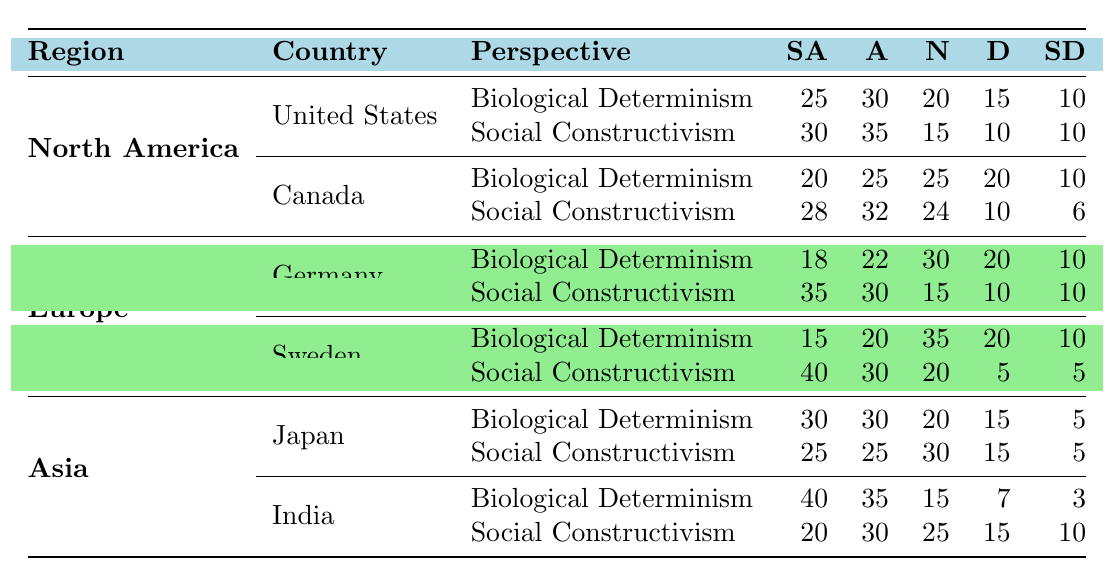What percentage of respondents in Canada agree with Social Constructivism? In Canada, for Social Constructivism, the 'Agree' category has a value of 32. To find the percentage of respondents who agree, we refer to the total counts in Social Constructivism: 28 (Strongly Agree) + 32 (Agree) + 24 (Neutral) + 10 (Disagree) + 6 (Strongly Disagree) = 100. The percentage that agree is (32/100) * 100 = 32%.
Answer: 32% Which country shows the highest level of agreement with Biological Determinism? Examining the values under Biological Determinism, India has the highest 'Strongly Agree' count at 40, while other countries have lower values (the highest is 30 in Japan and the US). Therefore, India shows the highest level of agreement.
Answer: India What is the average percentage of respondents in the United States who agree with Biological Determinism and Social Constructivism combined? For the United States, the values for agreeing (Strongly Agree + Agree) in Biological Determinism are 25 + 30 = 55, and for Social Constructivism are 30 + 35 = 65. Combining them gives: 55 + 65 = 120. There are 2 perspectives, so the average is 120 / 2 = 60%.
Answer: 60% Is it true that Sweden has a higher percentage of respondents agreeing with Social Constructivism than Germany? In Sweden, the combined agreement for Social Constructivism (Strongly Agree + Agree) is 40 + 30 = 70. For Germany, it's 35 + 30 = 65. 70 is greater than 65, thus it is true that Sweden has a higher percentage of agreement compared to Germany.
Answer: Yes What is the difference in the percentage of respondents who strongly agree with Biological Determinism between Japan and Canada? The 'Strongly Agree' count for Japan is 30 and for Canada, it's 20. To find the difference, we calculate: 30 (Japan) - 20 (Canada) = 10. Therefore, the difference in the percentage of respondents who strongly agree with Biological Determinism between these two countries is 10.
Answer: 10 